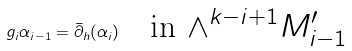<formula> <loc_0><loc_0><loc_500><loc_500>g _ { i } \alpha _ { i - 1 } = \bar { \partial } _ { h } ( \alpha _ { i } ) \quad \text {in $\wedge^{k-i+1}M^{\prime}_{i-1}$}</formula> 